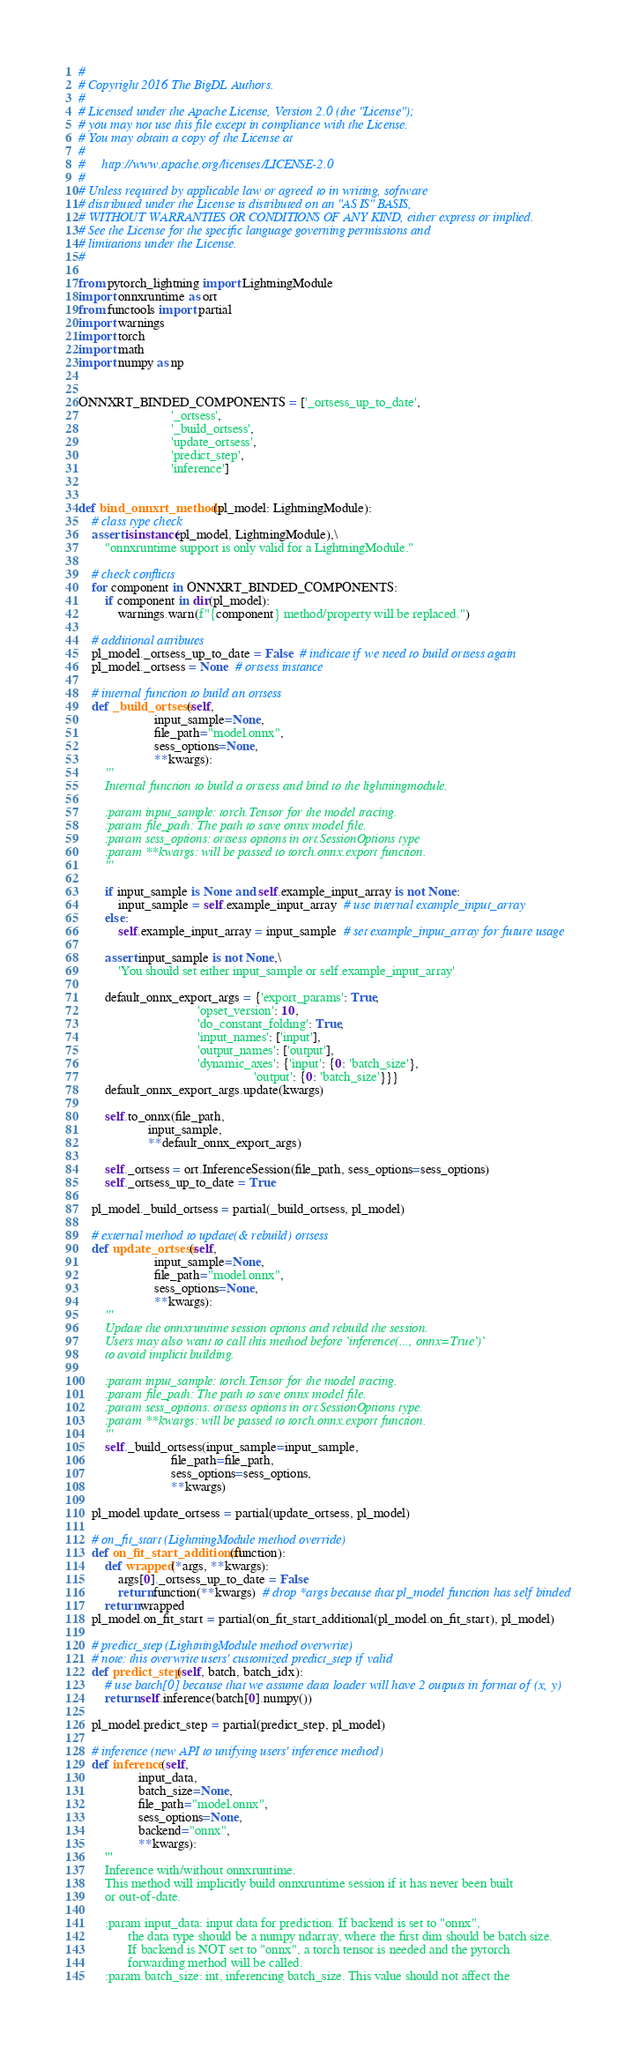<code> <loc_0><loc_0><loc_500><loc_500><_Python_>#
# Copyright 2016 The BigDL Authors.
#
# Licensed under the Apache License, Version 2.0 (the "License");
# you may not use this file except in compliance with the License.
# You may obtain a copy of the License at
#
#     http://www.apache.org/licenses/LICENSE-2.0
#
# Unless required by applicable law or agreed to in writing, software
# distributed under the License is distributed on an "AS IS" BASIS,
# WITHOUT WARRANTIES OR CONDITIONS OF ANY KIND, either express or implied.
# See the License for the specific language governing permissions and
# limitations under the License.
#

from pytorch_lightning import LightningModule
import onnxruntime as ort
from functools import partial
import warnings
import torch
import math
import numpy as np


ONNXRT_BINDED_COMPONENTS = ['_ortsess_up_to_date',
                            '_ortsess',
                            '_build_ortsess',
                            'update_ortsess',
                            'predict_step',
                            'inference']


def bind_onnxrt_methods(pl_model: LightningModule):
    # class type check
    assert isinstance(pl_model, LightningModule),\
        "onnxruntime support is only valid for a LightningModule."

    # check conflicts
    for component in ONNXRT_BINDED_COMPONENTS:
        if component in dir(pl_model):
            warnings.warn(f"{component} method/property will be replaced.")

    # additional attributes
    pl_model._ortsess_up_to_date = False  # indicate if we need to build ortsess again
    pl_model._ortsess = None  # ortsess instance

    # internal function to build an ortsess
    def _build_ortsess(self,
                       input_sample=None,
                       file_path="model.onnx",
                       sess_options=None,
                       **kwargs):
        '''
        Internal function to build a ortsess and bind to the lightningmodule.

        :param input_sample: torch.Tensor for the model tracing.
        :param file_path: The path to save onnx model file.
        :param sess_options: ortsess options in ort.SessionOptions type
        :param **kwargs: will be passed to torch.onnx.export function.
        '''

        if input_sample is None and self.example_input_array is not None:
            input_sample = self.example_input_array  # use internal example_input_array
        else:
            self.example_input_array = input_sample  # set example_input_array for future usage

        assert input_sample is not None,\
            'You should set either input_sample or self.example_input_array'

        default_onnx_export_args = {'export_params': True,
                                    'opset_version': 10,
                                    'do_constant_folding': True,
                                    'input_names': ['input'],
                                    'output_names': ['output'],
                                    'dynamic_axes': {'input': {0: 'batch_size'},
                                                     'output': {0: 'batch_size'}}}
        default_onnx_export_args.update(kwargs)

        self.to_onnx(file_path,
                     input_sample,
                     **default_onnx_export_args)

        self._ortsess = ort.InferenceSession(file_path, sess_options=sess_options)
        self._ortsess_up_to_date = True

    pl_model._build_ortsess = partial(_build_ortsess, pl_model)

    # external method to update(& rebuild) ortsess
    def update_ortsess(self,
                       input_sample=None,
                       file_path="model.onnx",
                       sess_options=None,
                       **kwargs):
        '''
        Update the onnxruntime session options and rebuild the session.
        Users may also want to call this method before `inference(..., onnx=True`)`
        to avoid implicit building.

        :param input_sample: torch.Tensor for the model tracing.
        :param file_path: The path to save onnx model file.
        :param sess_options: ortsess options in ort.SessionOptions type.
        :param **kwargs: will be passed to torch.onnx.export function.
        '''
        self._build_ortsess(input_sample=input_sample,
                            file_path=file_path,
                            sess_options=sess_options,
                            **kwargs)

    pl_model.update_ortsess = partial(update_ortsess, pl_model)

    # on_fit_start (LightningModule method override)
    def on_fit_start_additional(function):
        def wrapped(*args, **kwargs):
            args[0]._ortsess_up_to_date = False
            return function(**kwargs)  # drop *args because that pl_model function has self binded
        return wrapped
    pl_model.on_fit_start = partial(on_fit_start_additional(pl_model.on_fit_start), pl_model)

    # predict_step (LightningModule method overwrite)
    # note: this overwrite users' customized predict_step if valid
    def predict_step(self, batch, batch_idx):
        # use batch[0] because that we assume data loader will have 2 outputs in format of (x, y)
        return self.inference(batch[0].numpy())

    pl_model.predict_step = partial(predict_step, pl_model)

    # inference (new API to unifying users' inference method)
    def inference(self,
                  input_data,
                  batch_size=None,
                  file_path="model.onnx",
                  sess_options=None,
                  backend="onnx",
                  **kwargs):
        '''
        Inference with/without onnxruntime.
        This method will implicitly build onnxruntime session if it has never been built
        or out-of-date.

        :param input_data: input data for prediction. If backend is set to "onnx",
               the data type should be a numpy ndarray, where the first dim should be batch size.
               If backend is NOT set to "onnx", a torch tensor is needed and the pytorch
               forwarding method will be called.
        :param batch_size: int, inferencing batch_size. This value should not affect the</code> 